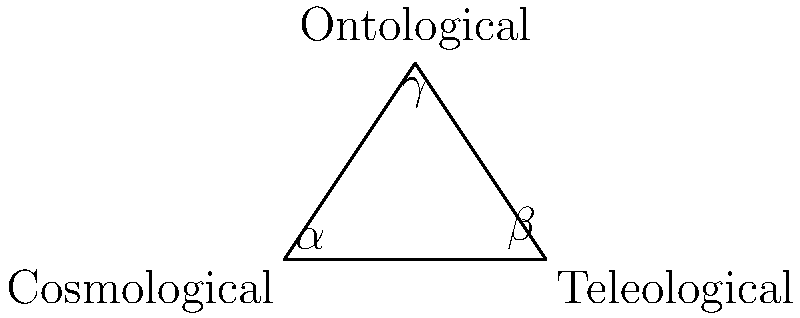In the triangle representing the classical arguments for God's existence, if the angle corresponding to the cosmological argument ($\alpha$) is 60°, and the angle for the teleological argument ($\beta$) is 45°, what is the measure of the angle representing the ontological argument ($\gamma$)? To solve this problem, we'll use the fundamental property of triangles that the sum of all interior angles is always 180°. Here's the step-by-step solution:

1. Recall the triangle angle sum theorem: $\alpha + \beta + \gamma = 180°$

2. We're given two angles:
   $\alpha = 60°$ (cosmological argument)
   $\beta = 45°$ (teleological argument)

3. Substitute these values into the equation:
   $60° + 45° + \gamma = 180°$

4. Simplify the left side:
   $105° + \gamma = 180°$

5. Subtract 105° from both sides:
   $\gamma = 180° - 105°$

6. Perform the subtraction:
   $\gamma = 75°$

Therefore, the angle representing the ontological argument ($\gamma$) measures 75°.
Answer: 75° 